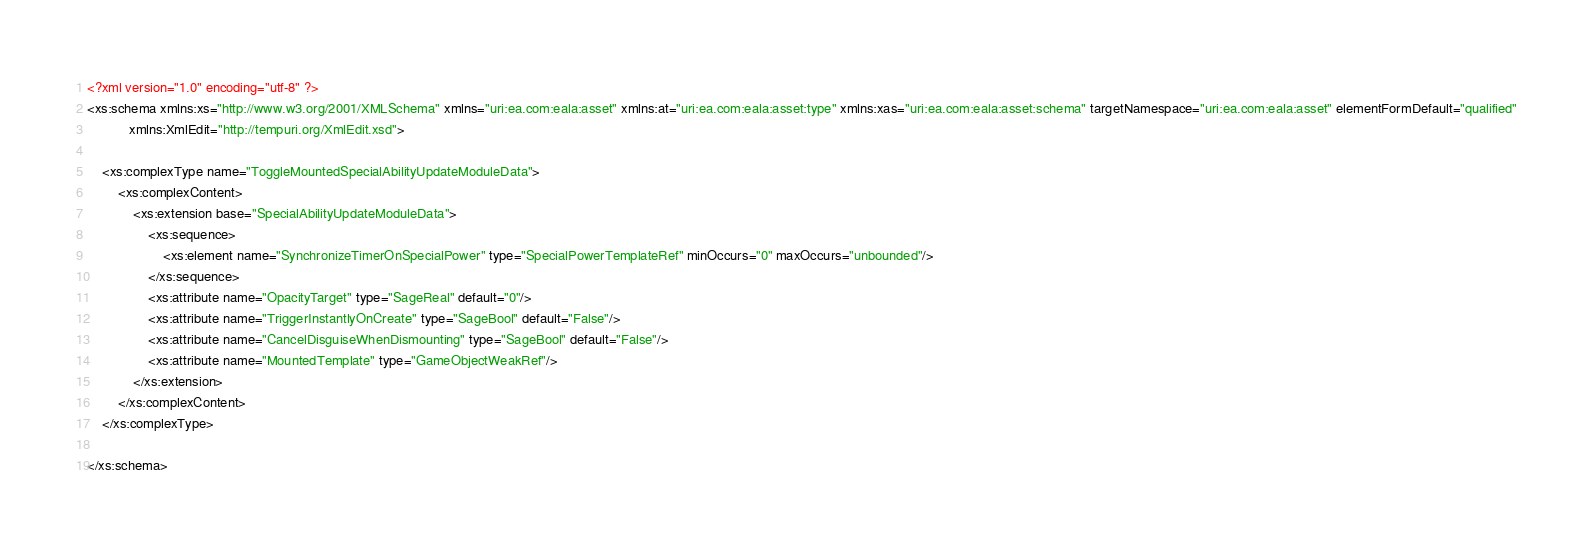Convert code to text. <code><loc_0><loc_0><loc_500><loc_500><_XML_><?xml version="1.0" encoding="utf-8" ?>
<xs:schema xmlns:xs="http://www.w3.org/2001/XMLSchema" xmlns="uri:ea.com:eala:asset" xmlns:at="uri:ea.com:eala:asset:type" xmlns:xas="uri:ea.com:eala:asset:schema" targetNamespace="uri:ea.com:eala:asset" elementFormDefault="qualified"
           xmlns:XmlEdit="http://tempuri.org/XmlEdit.xsd">

    <xs:complexType name="ToggleMountedSpecialAbilityUpdateModuleData">
        <xs:complexContent>
            <xs:extension base="SpecialAbilityUpdateModuleData">
                <xs:sequence>
                    <xs:element name="SynchronizeTimerOnSpecialPower" type="SpecialPowerTemplateRef" minOccurs="0" maxOccurs="unbounded"/>
                </xs:sequence>
                <xs:attribute name="OpacityTarget" type="SageReal" default="0"/>
                <xs:attribute name="TriggerInstantlyOnCreate" type="SageBool" default="False"/>
                <xs:attribute name="CancelDisguiseWhenDismounting" type="SageBool" default="False"/>
                <xs:attribute name="MountedTemplate" type="GameObjectWeakRef"/>
            </xs:extension>
        </xs:complexContent>
    </xs:complexType>

</xs:schema>
</code> 